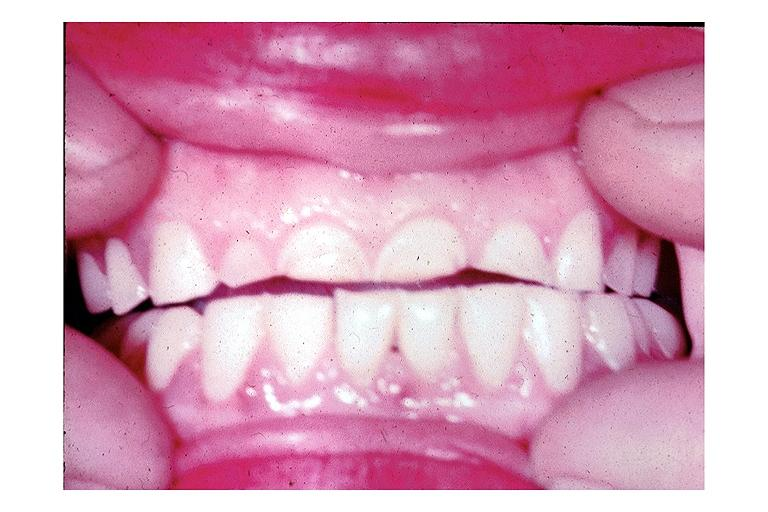what does this image show?
Answer the question using a single word or phrase. Attrition 